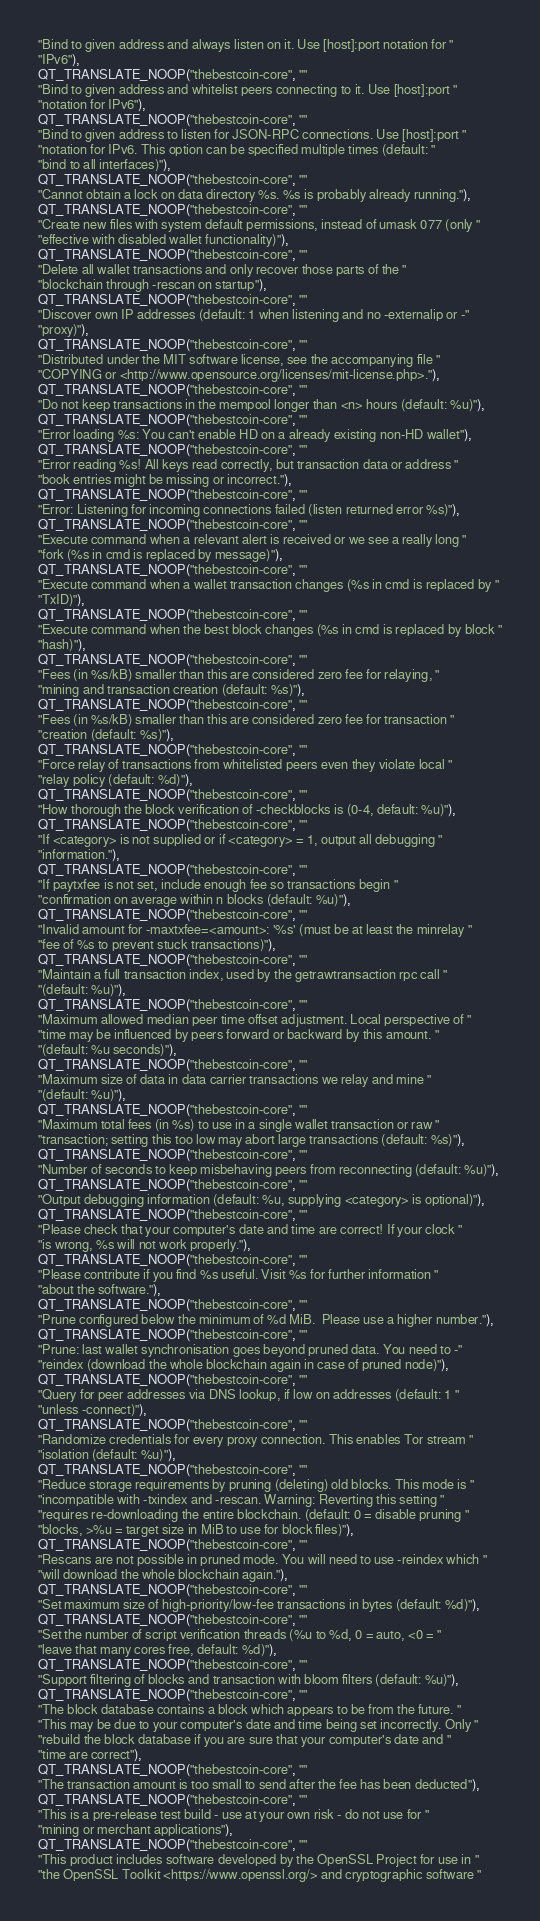<code> <loc_0><loc_0><loc_500><loc_500><_C++_>"Bind to given address and always listen on it. Use [host]:port notation for "
"IPv6"),
QT_TRANSLATE_NOOP("thebestcoin-core", ""
"Bind to given address and whitelist peers connecting to it. Use [host]:port "
"notation for IPv6"),
QT_TRANSLATE_NOOP("thebestcoin-core", ""
"Bind to given address to listen for JSON-RPC connections. Use [host]:port "
"notation for IPv6. This option can be specified multiple times (default: "
"bind to all interfaces)"),
QT_TRANSLATE_NOOP("thebestcoin-core", ""
"Cannot obtain a lock on data directory %s. %s is probably already running."),
QT_TRANSLATE_NOOP("thebestcoin-core", ""
"Create new files with system default permissions, instead of umask 077 (only "
"effective with disabled wallet functionality)"),
QT_TRANSLATE_NOOP("thebestcoin-core", ""
"Delete all wallet transactions and only recover those parts of the "
"blockchain through -rescan on startup"),
QT_TRANSLATE_NOOP("thebestcoin-core", ""
"Discover own IP addresses (default: 1 when listening and no -externalip or -"
"proxy)"),
QT_TRANSLATE_NOOP("thebestcoin-core", ""
"Distributed under the MIT software license, see the accompanying file "
"COPYING or <http://www.opensource.org/licenses/mit-license.php>."),
QT_TRANSLATE_NOOP("thebestcoin-core", ""
"Do not keep transactions in the mempool longer than <n> hours (default: %u)"),
QT_TRANSLATE_NOOP("thebestcoin-core", ""
"Error loading %s: You can't enable HD on a already existing non-HD wallet"),
QT_TRANSLATE_NOOP("thebestcoin-core", ""
"Error reading %s! All keys read correctly, but transaction data or address "
"book entries might be missing or incorrect."),
QT_TRANSLATE_NOOP("thebestcoin-core", ""
"Error: Listening for incoming connections failed (listen returned error %s)"),
QT_TRANSLATE_NOOP("thebestcoin-core", ""
"Execute command when a relevant alert is received or we see a really long "
"fork (%s in cmd is replaced by message)"),
QT_TRANSLATE_NOOP("thebestcoin-core", ""
"Execute command when a wallet transaction changes (%s in cmd is replaced by "
"TxID)"),
QT_TRANSLATE_NOOP("thebestcoin-core", ""
"Execute command when the best block changes (%s in cmd is replaced by block "
"hash)"),
QT_TRANSLATE_NOOP("thebestcoin-core", ""
"Fees (in %s/kB) smaller than this are considered zero fee for relaying, "
"mining and transaction creation (default: %s)"),
QT_TRANSLATE_NOOP("thebestcoin-core", ""
"Fees (in %s/kB) smaller than this are considered zero fee for transaction "
"creation (default: %s)"),
QT_TRANSLATE_NOOP("thebestcoin-core", ""
"Force relay of transactions from whitelisted peers even they violate local "
"relay policy (default: %d)"),
QT_TRANSLATE_NOOP("thebestcoin-core", ""
"How thorough the block verification of -checkblocks is (0-4, default: %u)"),
QT_TRANSLATE_NOOP("thebestcoin-core", ""
"If <category> is not supplied or if <category> = 1, output all debugging "
"information."),
QT_TRANSLATE_NOOP("thebestcoin-core", ""
"If paytxfee is not set, include enough fee so transactions begin "
"confirmation on average within n blocks (default: %u)"),
QT_TRANSLATE_NOOP("thebestcoin-core", ""
"Invalid amount for -maxtxfee=<amount>: '%s' (must be at least the minrelay "
"fee of %s to prevent stuck transactions)"),
QT_TRANSLATE_NOOP("thebestcoin-core", ""
"Maintain a full transaction index, used by the getrawtransaction rpc call "
"(default: %u)"),
QT_TRANSLATE_NOOP("thebestcoin-core", ""
"Maximum allowed median peer time offset adjustment. Local perspective of "
"time may be influenced by peers forward or backward by this amount. "
"(default: %u seconds)"),
QT_TRANSLATE_NOOP("thebestcoin-core", ""
"Maximum size of data in data carrier transactions we relay and mine "
"(default: %u)"),
QT_TRANSLATE_NOOP("thebestcoin-core", ""
"Maximum total fees (in %s) to use in a single wallet transaction or raw "
"transaction; setting this too low may abort large transactions (default: %s)"),
QT_TRANSLATE_NOOP("thebestcoin-core", ""
"Number of seconds to keep misbehaving peers from reconnecting (default: %u)"),
QT_TRANSLATE_NOOP("thebestcoin-core", ""
"Output debugging information (default: %u, supplying <category> is optional)"),
QT_TRANSLATE_NOOP("thebestcoin-core", ""
"Please check that your computer's date and time are correct! If your clock "
"is wrong, %s will not work properly."),
QT_TRANSLATE_NOOP("thebestcoin-core", ""
"Please contribute if you find %s useful. Visit %s for further information "
"about the software."),
QT_TRANSLATE_NOOP("thebestcoin-core", ""
"Prune configured below the minimum of %d MiB.  Please use a higher number."),
QT_TRANSLATE_NOOP("thebestcoin-core", ""
"Prune: last wallet synchronisation goes beyond pruned data. You need to -"
"reindex (download the whole blockchain again in case of pruned node)"),
QT_TRANSLATE_NOOP("thebestcoin-core", ""
"Query for peer addresses via DNS lookup, if low on addresses (default: 1 "
"unless -connect)"),
QT_TRANSLATE_NOOP("thebestcoin-core", ""
"Randomize credentials for every proxy connection. This enables Tor stream "
"isolation (default: %u)"),
QT_TRANSLATE_NOOP("thebestcoin-core", ""
"Reduce storage requirements by pruning (deleting) old blocks. This mode is "
"incompatible with -txindex and -rescan. Warning: Reverting this setting "
"requires re-downloading the entire blockchain. (default: 0 = disable pruning "
"blocks, >%u = target size in MiB to use for block files)"),
QT_TRANSLATE_NOOP("thebestcoin-core", ""
"Rescans are not possible in pruned mode. You will need to use -reindex which "
"will download the whole blockchain again."),
QT_TRANSLATE_NOOP("thebestcoin-core", ""
"Set maximum size of high-priority/low-fee transactions in bytes (default: %d)"),
QT_TRANSLATE_NOOP("thebestcoin-core", ""
"Set the number of script verification threads (%u to %d, 0 = auto, <0 = "
"leave that many cores free, default: %d)"),
QT_TRANSLATE_NOOP("thebestcoin-core", ""
"Support filtering of blocks and transaction with bloom filters (default: %u)"),
QT_TRANSLATE_NOOP("thebestcoin-core", ""
"The block database contains a block which appears to be from the future. "
"This may be due to your computer's date and time being set incorrectly. Only "
"rebuild the block database if you are sure that your computer's date and "
"time are correct"),
QT_TRANSLATE_NOOP("thebestcoin-core", ""
"The transaction amount is too small to send after the fee has been deducted"),
QT_TRANSLATE_NOOP("thebestcoin-core", ""
"This is a pre-release test build - use at your own risk - do not use for "
"mining or merchant applications"),
QT_TRANSLATE_NOOP("thebestcoin-core", ""
"This product includes software developed by the OpenSSL Project for use in "
"the OpenSSL Toolkit <https://www.openssl.org/> and cryptographic software "</code> 